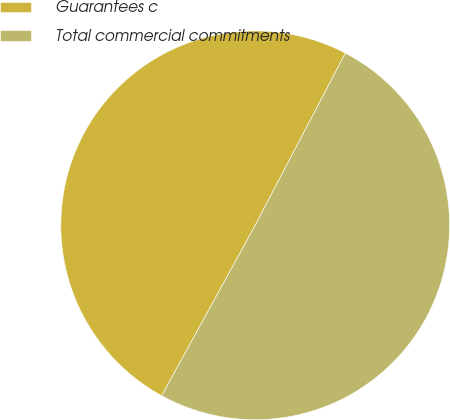Convert chart. <chart><loc_0><loc_0><loc_500><loc_500><pie_chart><fcel>Guarantees c<fcel>Total commercial commitments<nl><fcel>49.69%<fcel>50.31%<nl></chart> 